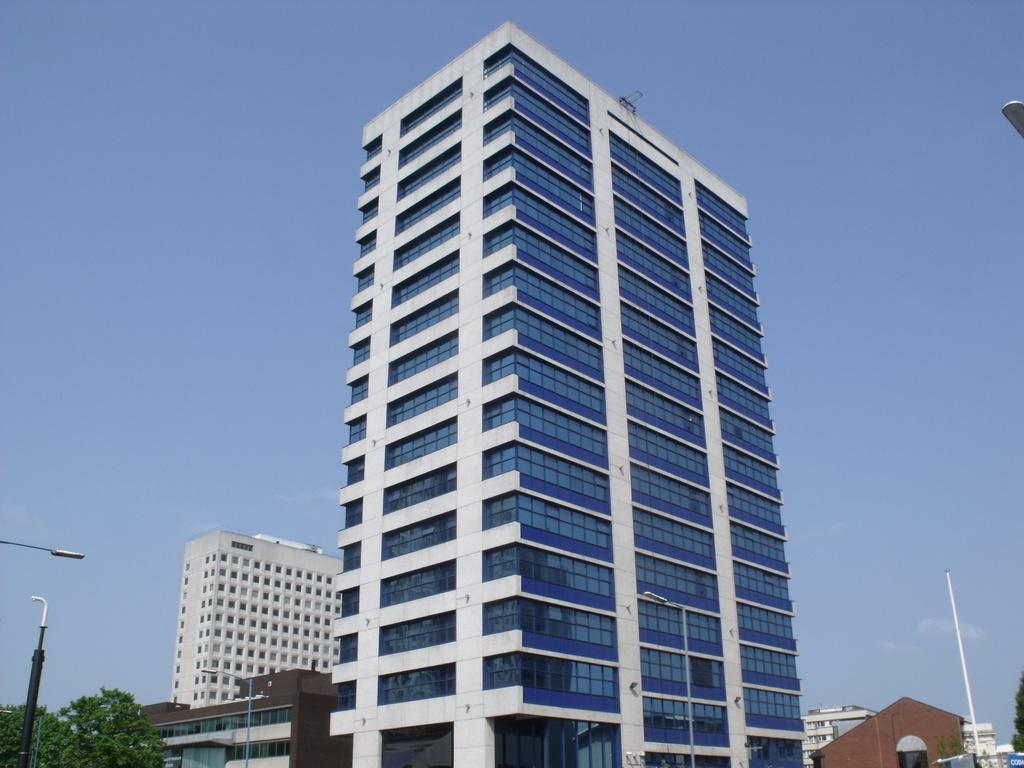What type of structures are present in the image? There are multiple buildings in the image. What can be seen on both sides of the buildings? There are poles and trees on both sides of the buildings. What is used for illumination in the image? There are street lights in the image. What is visible in the background of the image? The sky is visible in the background of the image. What type of emotion is displayed by the cabbage in the image? There is no cabbage present in the image, and therefore no emotion can be attributed to it. 